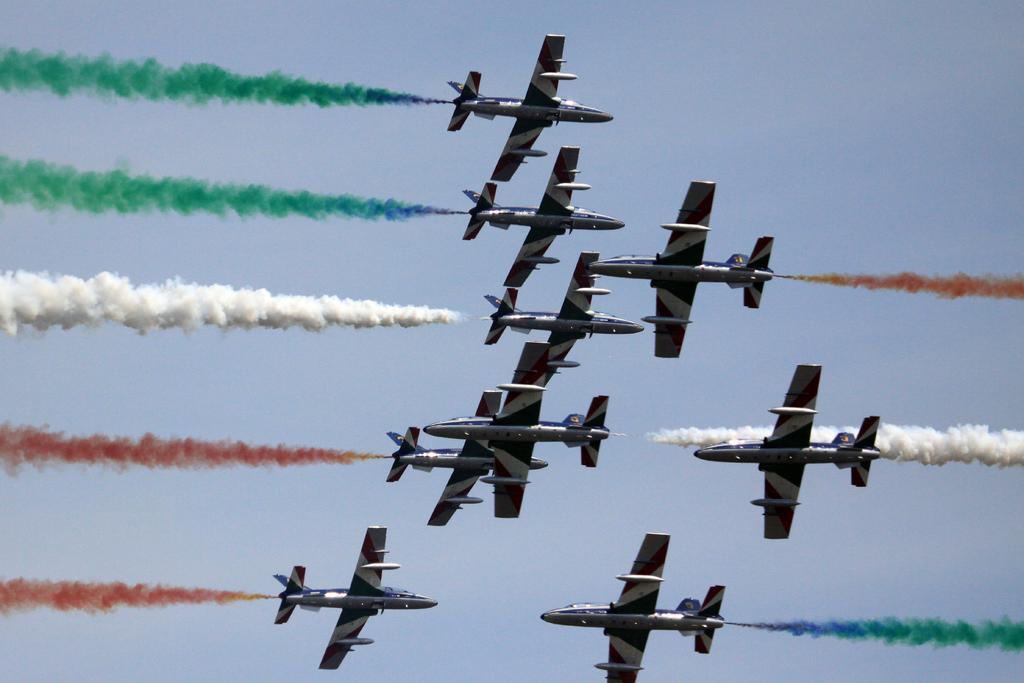How would you summarize this image in a sentence or two? In this image in the center there are some aircraft and some dog is coming out, and in the background there is sky. 